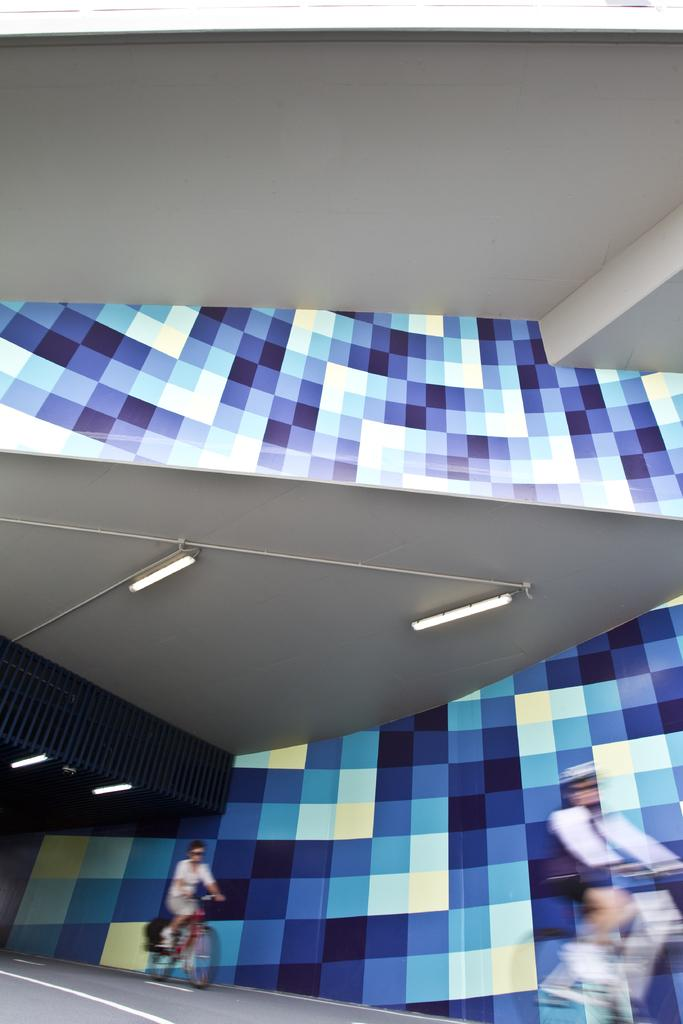How many people are in the image? There are two persons in the image. What are the persons doing in the image? The persons are riding bicycles. Where are the bicycles located? The bicycles are on a road. What can be seen in the background of the image? There are lights and a wall visible in the background. What type of fear can be seen on the faces of the persons in the image? There is no indication of fear on the faces of the persons in the image; they appear to be riding bicycles. What type of partner is present in the image? There is no partner present in the image; only two persons riding bicycles are visible. 